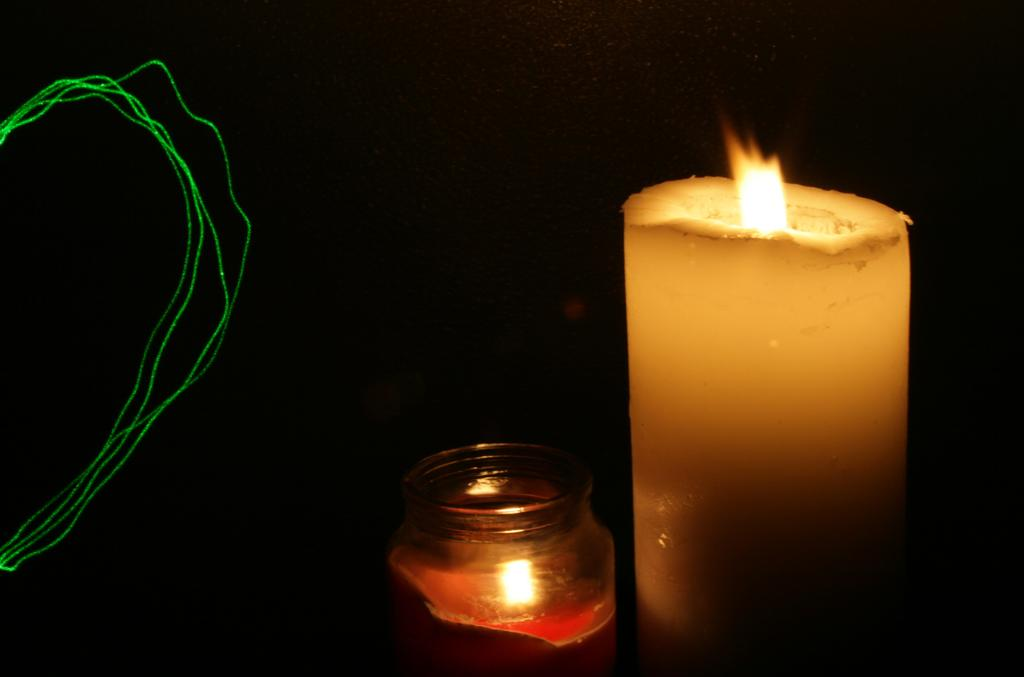What object is present in the image that produces light? There is a candle in the image that has a flame. What type of candle is in the image? The candle in the image is in a jar. What is the lighting condition in the background of the image? The background of the image is dark. What else can be seen to the left in the image? There are wires visible to the left in the image. What type of education is the plant receiving in the image? There is no plant present in the image, so it cannot be receiving any education. 